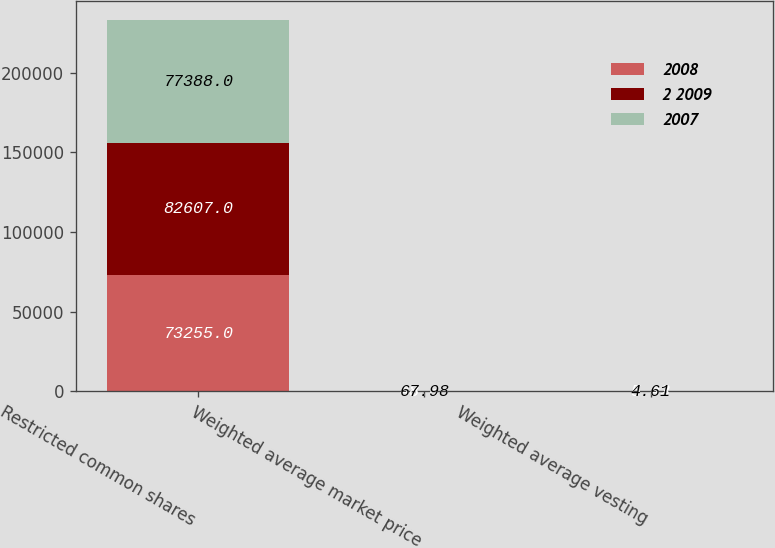<chart> <loc_0><loc_0><loc_500><loc_500><stacked_bar_chart><ecel><fcel>Restricted common shares<fcel>Weighted average market price<fcel>Weighted average vesting<nl><fcel>2008<fcel>73255<fcel>43.68<fcel>4.42<nl><fcel>2 2009<fcel>82607<fcel>68.98<fcel>5.03<nl><fcel>2007<fcel>77388<fcel>67.98<fcel>4.61<nl></chart> 